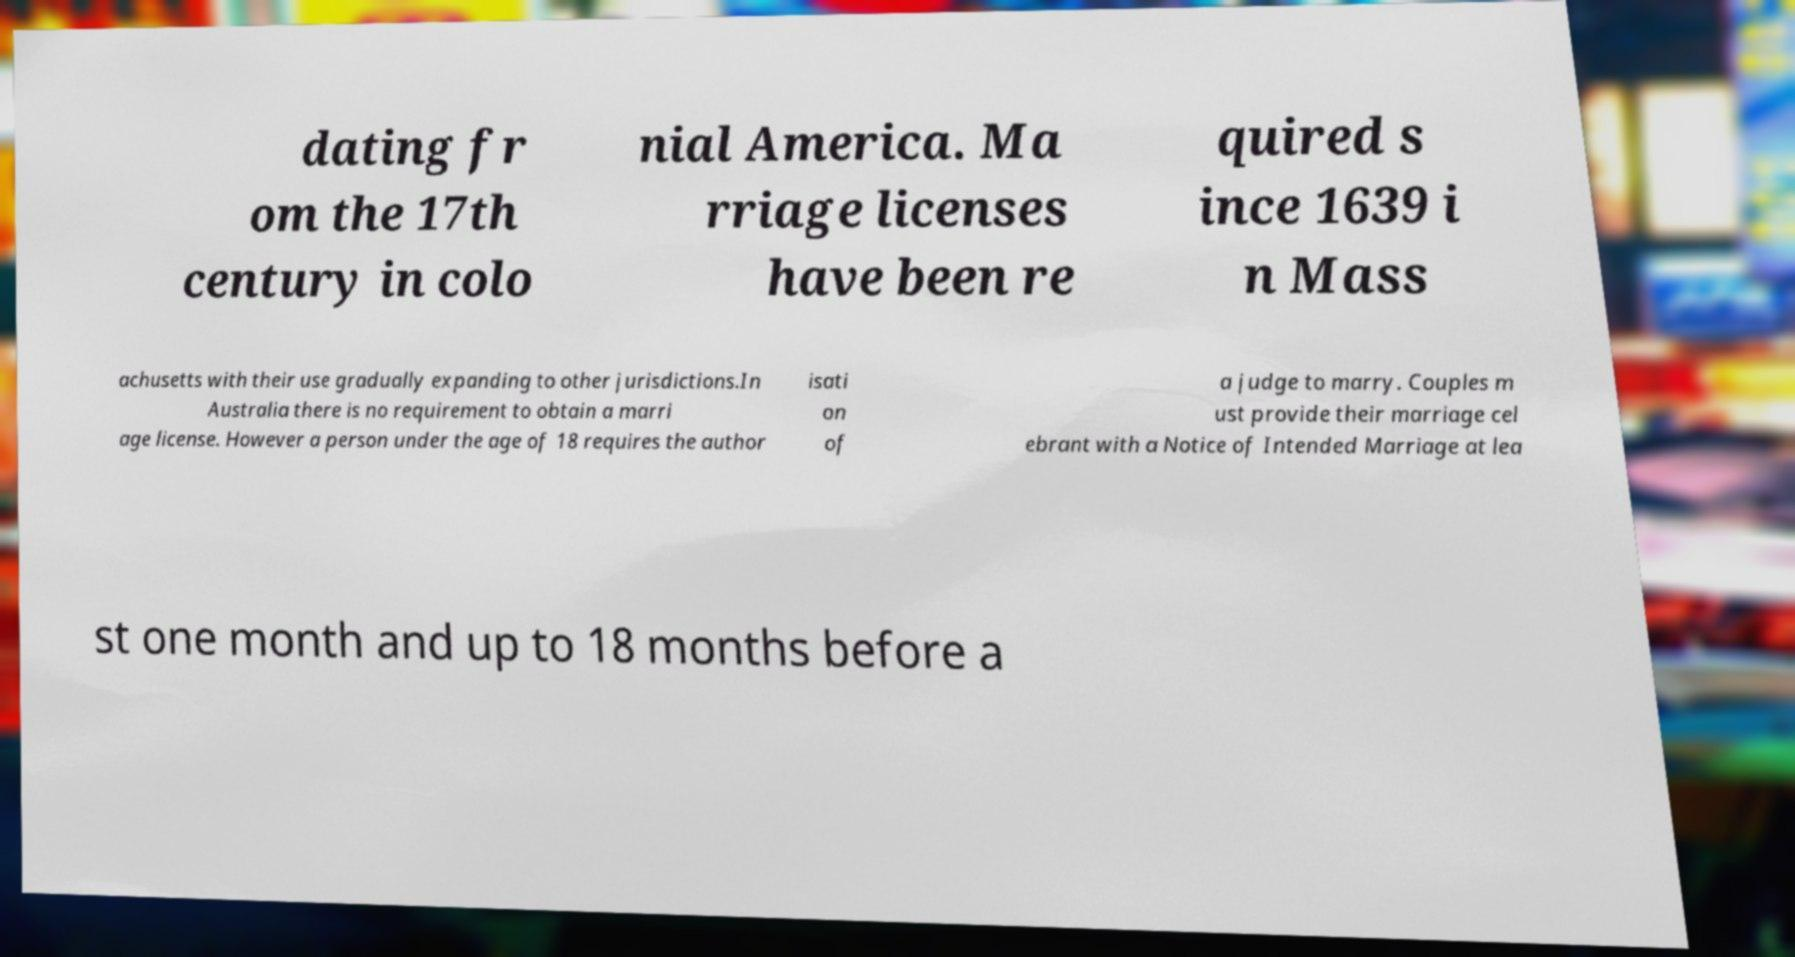Could you extract and type out the text from this image? dating fr om the 17th century in colo nial America. Ma rriage licenses have been re quired s ince 1639 i n Mass achusetts with their use gradually expanding to other jurisdictions.In Australia there is no requirement to obtain a marri age license. However a person under the age of 18 requires the author isati on of a judge to marry. Couples m ust provide their marriage cel ebrant with a Notice of Intended Marriage at lea st one month and up to 18 months before a 